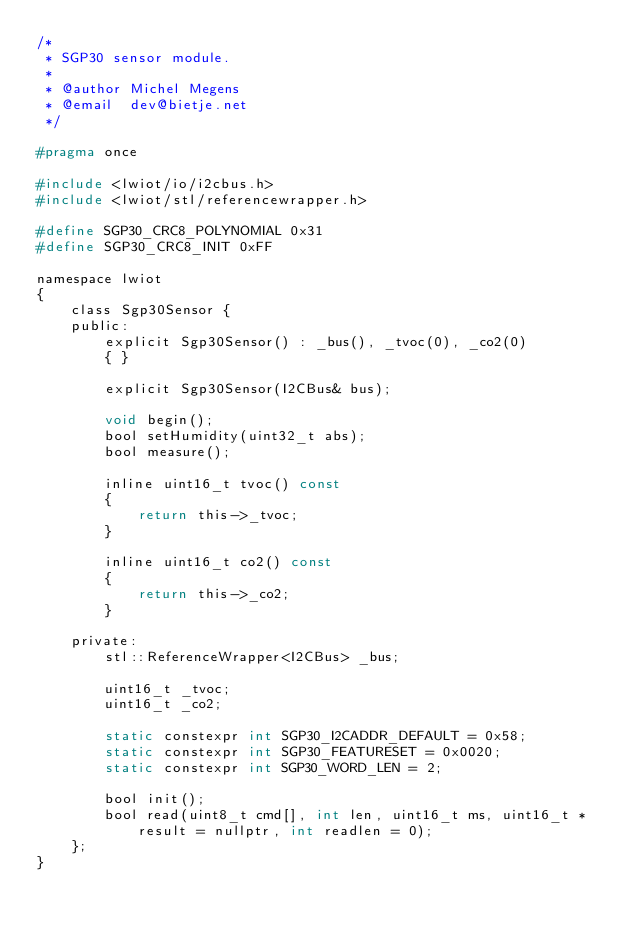<code> <loc_0><loc_0><loc_500><loc_500><_C_>/*
 * SGP30 sensor module.
 *
 * @author Michel Megens
 * @email  dev@bietje.net
 */

#pragma once

#include <lwiot/io/i2cbus.h>
#include <lwiot/stl/referencewrapper.h>

#define SGP30_CRC8_POLYNOMIAL 0x31
#define SGP30_CRC8_INIT 0xFF

namespace lwiot
{
	class Sgp30Sensor {
	public:
		explicit Sgp30Sensor() : _bus(), _tvoc(0), _co2(0)
		{ }

		explicit Sgp30Sensor(I2CBus& bus);

		void begin();
		bool setHumidity(uint32_t abs);
		bool measure();

		inline uint16_t tvoc() const
		{
			return this->_tvoc;
		}

		inline uint16_t co2() const
		{
			return this->_co2;
		}

	private:
		stl::ReferenceWrapper<I2CBus> _bus;

		uint16_t _tvoc;
		uint16_t _co2;

		static constexpr int SGP30_I2CADDR_DEFAULT = 0x58;
		static constexpr int SGP30_FEATURESET = 0x0020;
		static constexpr int SGP30_WORD_LEN = 2;

		bool init();
		bool read(uint8_t cmd[], int len, uint16_t ms, uint16_t *result = nullptr, int readlen = 0);
	};
}
</code> 